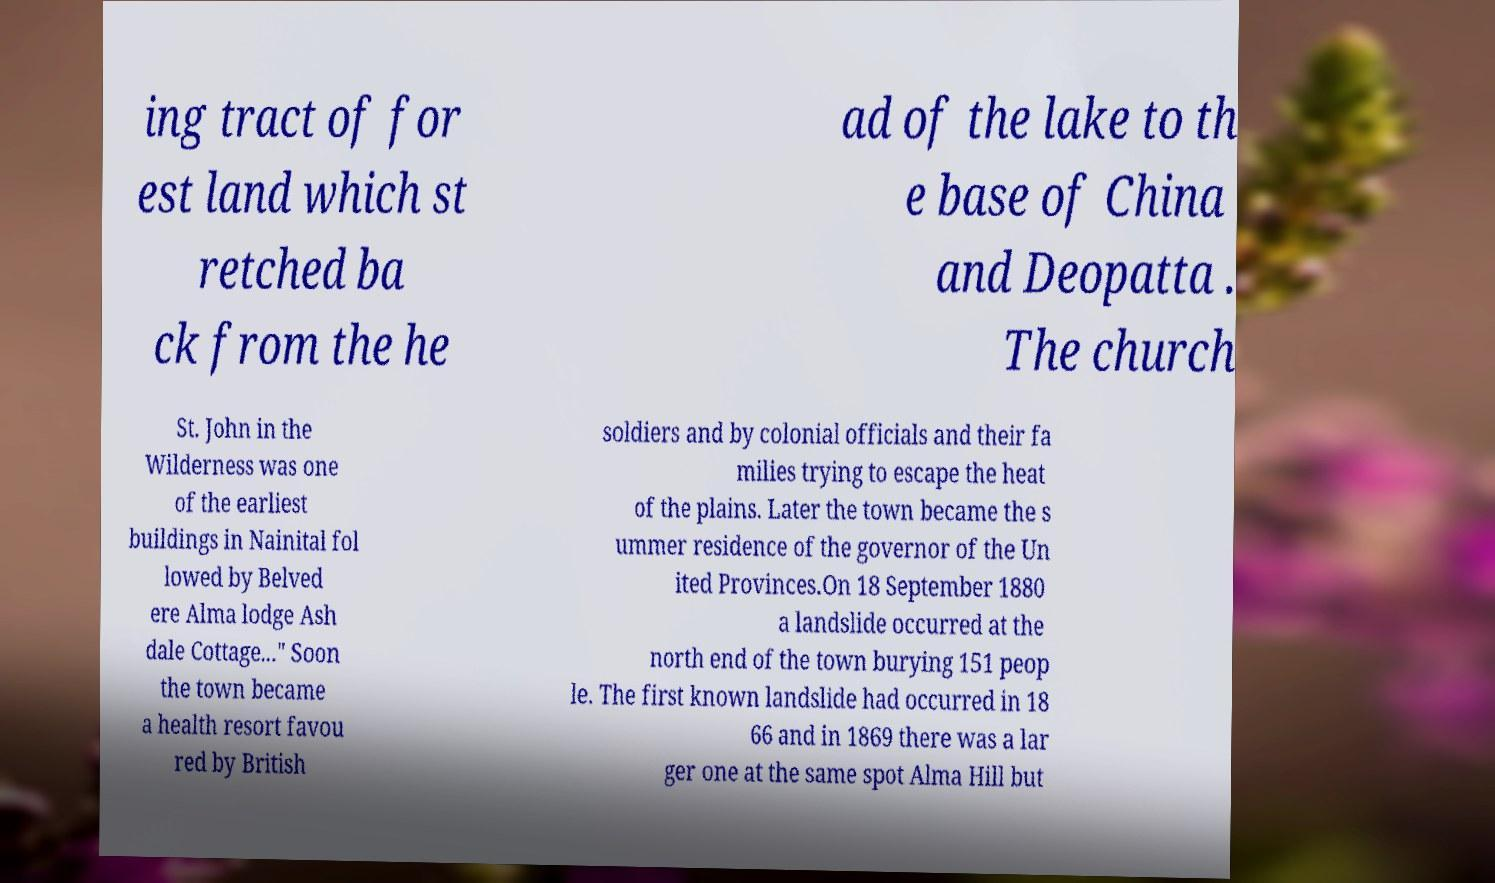Please read and relay the text visible in this image. What does it say? ing tract of for est land which st retched ba ck from the he ad of the lake to th e base of China and Deopatta . The church St. John in the Wilderness was one of the earliest buildings in Nainital fol lowed by Belved ere Alma lodge Ash dale Cottage..." Soon the town became a health resort favou red by British soldiers and by colonial officials and their fa milies trying to escape the heat of the plains. Later the town became the s ummer residence of the governor of the Un ited Provinces.On 18 September 1880 a landslide occurred at the north end of the town burying 151 peop le. The first known landslide had occurred in 18 66 and in 1869 there was a lar ger one at the same spot Alma Hill but 